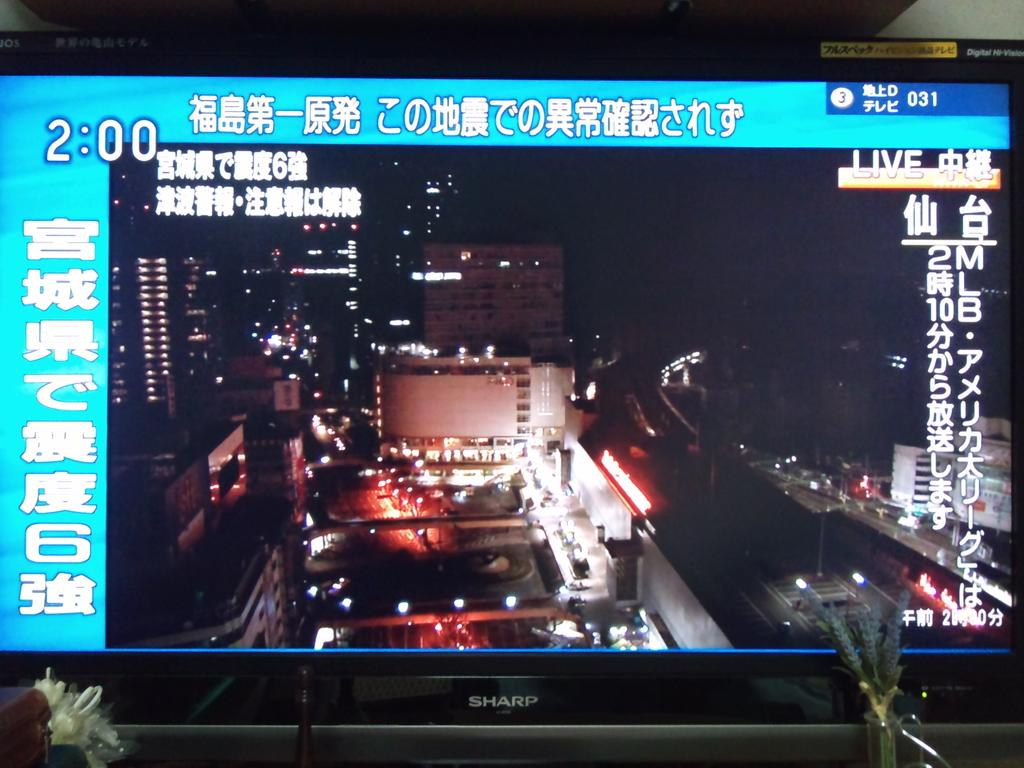<image>
Relay a brief, clear account of the picture shown. A Sharp TV screen says that it is currently 2:00. 